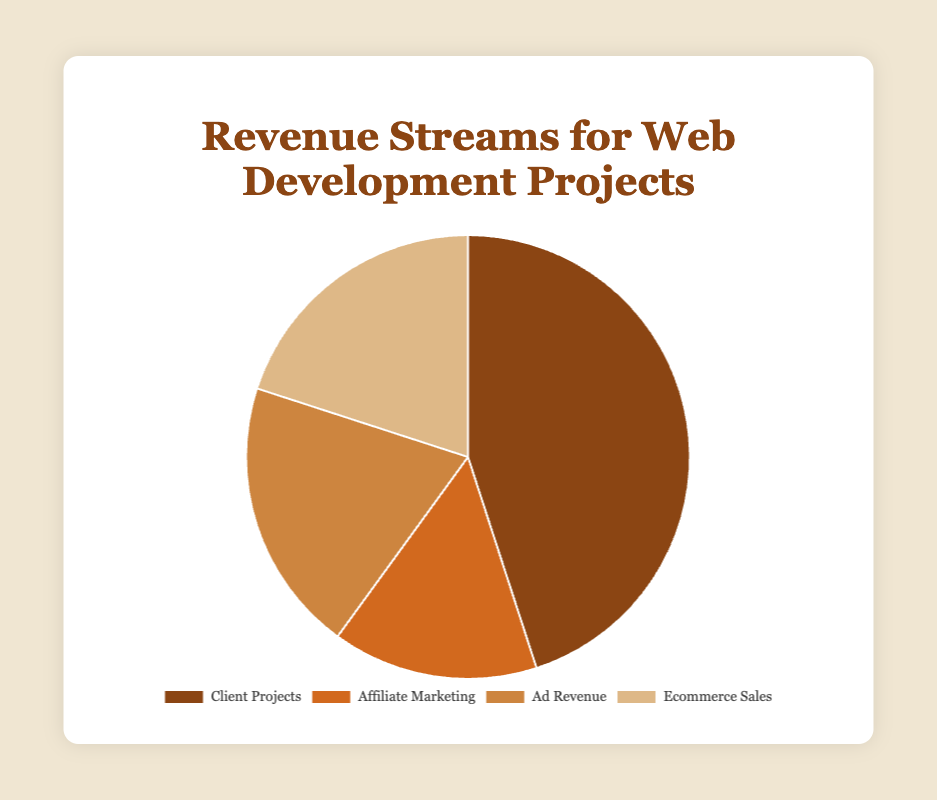What is the largest revenue stream for web development projects? The four revenue streams are shown as segments on the pie chart, and the segment with the highest percentage is for Client Projects, which is 45%.
Answer: Client Projects What percentage of the total revenue comes from Affiliate Marketing and Ad Revenue combined? Based on the pie chart, Affiliate Marketing accounts for 15% of the total revenue and Ad Revenue accounts for 20%. Adding these together, we get 15% + 20% = 35%.
Answer: 35% Which revenue stream is represented by the lightest color segment? The pie chart uses different colors for each revenue stream segment, with the lightest color being the one used for Ecommerce Sales.
Answer: Ecommerce Sales What is the difference in percentage points between the highest and lowest revenue streams? The highest revenue stream is Client Projects at 45%, and the lowest is Affiliate Marketing at 15%. The difference is 45% - 15% = 30%.
Answer: 30% How do Ad Revenue and Ecommerce Sales compare in terms of their contribution to the total revenue? According to the pie chart, Ad Revenue and Ecommerce Sales both contribute 20% to the total revenue, so they are equal.
Answer: Equal If the total revenue is $100,000, how much of it is attributed to Client Projects? Client Projects account for 45% of the total revenue. Therefore, 45% of $100,000 can be calculated by (45/100) * 100,000 = $45,000.
Answer: $45,000 What is the average percentage contribution of Ad Revenue and Ecommerce Sales? Both Ad Revenue and Ecommerce Sales contribute 20% each. The average percentage contribution can be calculated as (20% + 20%) / 2 = 20%.
Answer: 20% How many revenue streams have a contribution of 20% or more? From the pie chart, Client Projects (45%), Ad Revenue (20%), and Ecommerce Sales (20%) all have contributions of 20% or more. Thus, there are three revenue streams that meet this criterion.
Answer: 3 